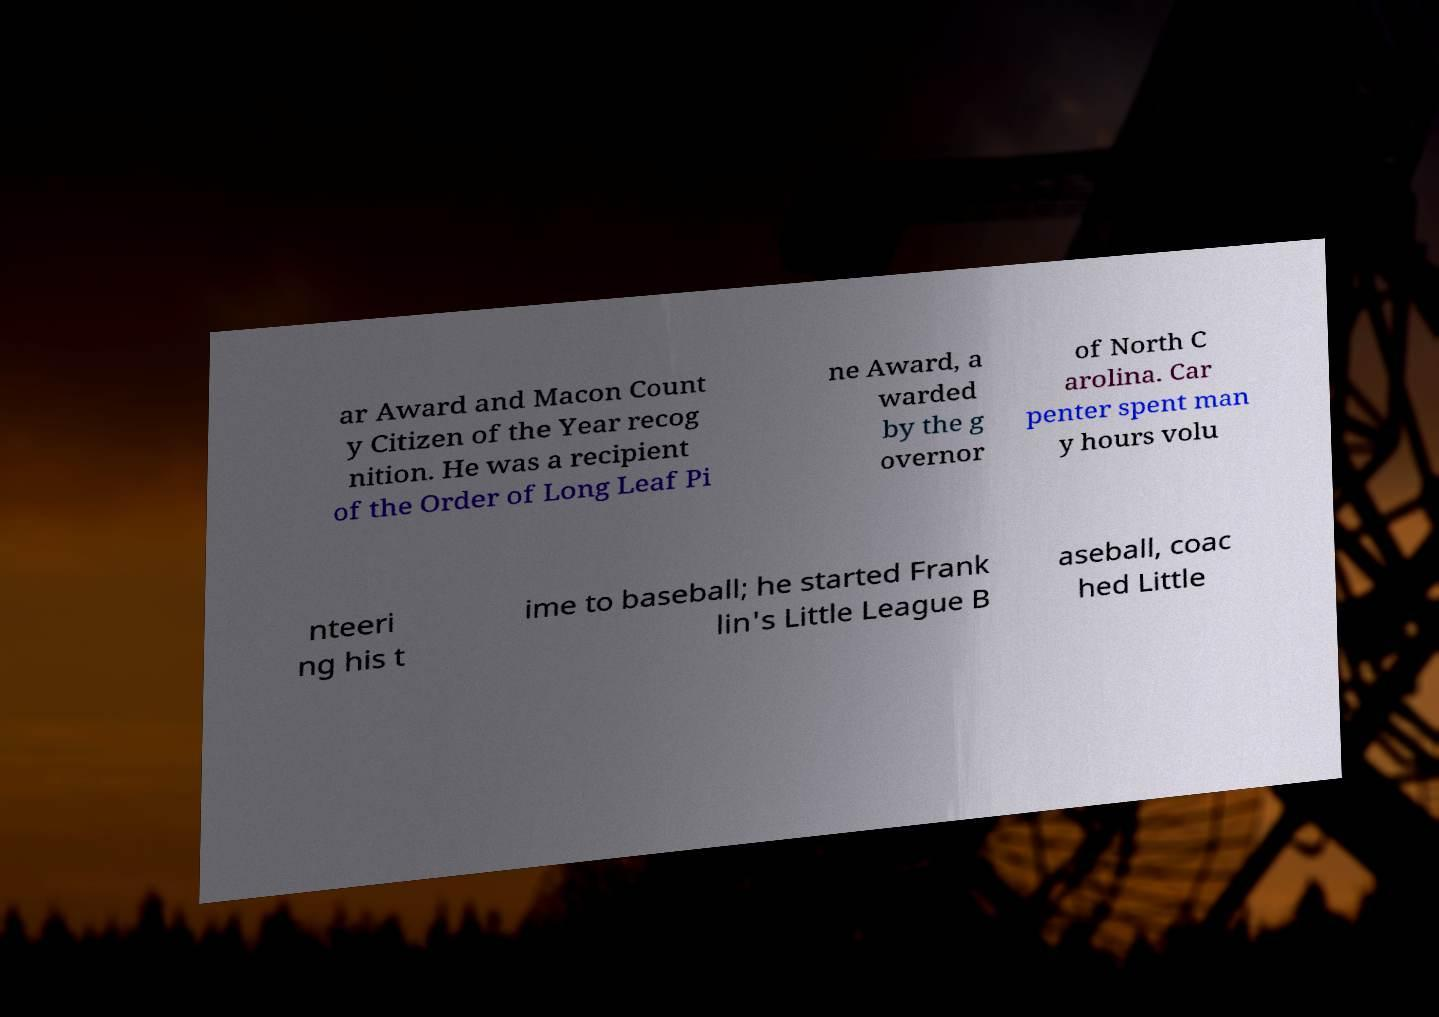What messages or text are displayed in this image? I need them in a readable, typed format. ar Award and Macon Count y Citizen of the Year recog nition. He was a recipient of the Order of Long Leaf Pi ne Award, a warded by the g overnor of North C arolina. Car penter spent man y hours volu nteeri ng his t ime to baseball; he started Frank lin's Little League B aseball, coac hed Little 